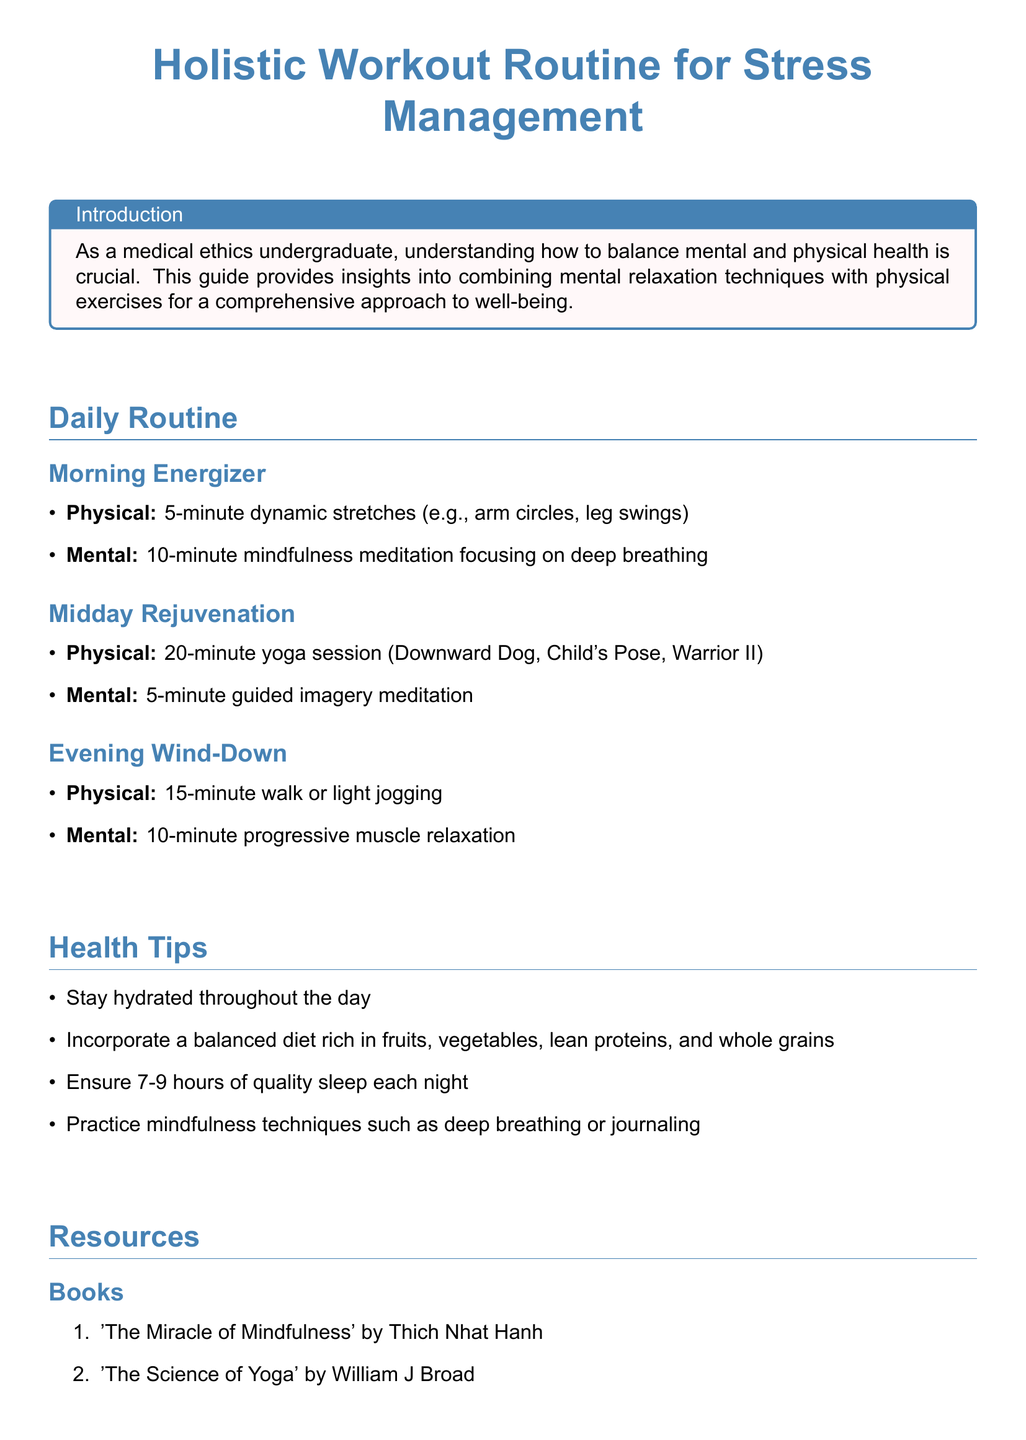What is the main focus of the document? The document focuses on combining mental relaxation techniques with physical exercises for a comprehensive approach to well-being.
Answer: Holistic Workout Routine for Stress Management How long is the mindfulness meditation in the morning? The morning routine specifies a 10-minute mindfulness meditation focusing on deep breathing.
Answer: 10 minutes What is included in the Midday Rejuvenation session? The Midday Rejuvenation section includes a 20-minute yoga session and a 5-minute guided imagery meditation.
Answer: 20-minute yoga session, 5-minute guided imagery meditation How many hours of sleep does the document recommend? The health tips section mentions ensuring 7-9 hours of quality sleep each night.
Answer: 7-9 hours What is the title of one recommended book? The resources section lists books, one being 'The Miracle of Mindfulness' by Thich Nhat Hanh.
Answer: The Miracle of Mindfulness Which app is suggested for guided meditation? The resources section includes apps, with Headspace being recommended for guided meditation and mindfulness exercises.
Answer: Headspace What type of exercise is suggested for the Evening Wind-Down? The Evening Wind-Down suggests a 15-minute walk or light jogging as part of the routine.
Answer: 15-minute walk, light jogging What mindfulness technique is mentioned for evening relaxation? The document mentions a 10-minute progressive muscle relaxation for evening mental relaxation.
Answer: 10-minute progressive muscle relaxation 